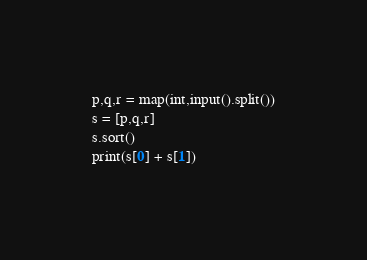Convert code to text. <code><loc_0><loc_0><loc_500><loc_500><_Python_>p,q,r = map(int,input().split())
s = [p,q,r]
s.sort()
print(s[0] + s[1])</code> 